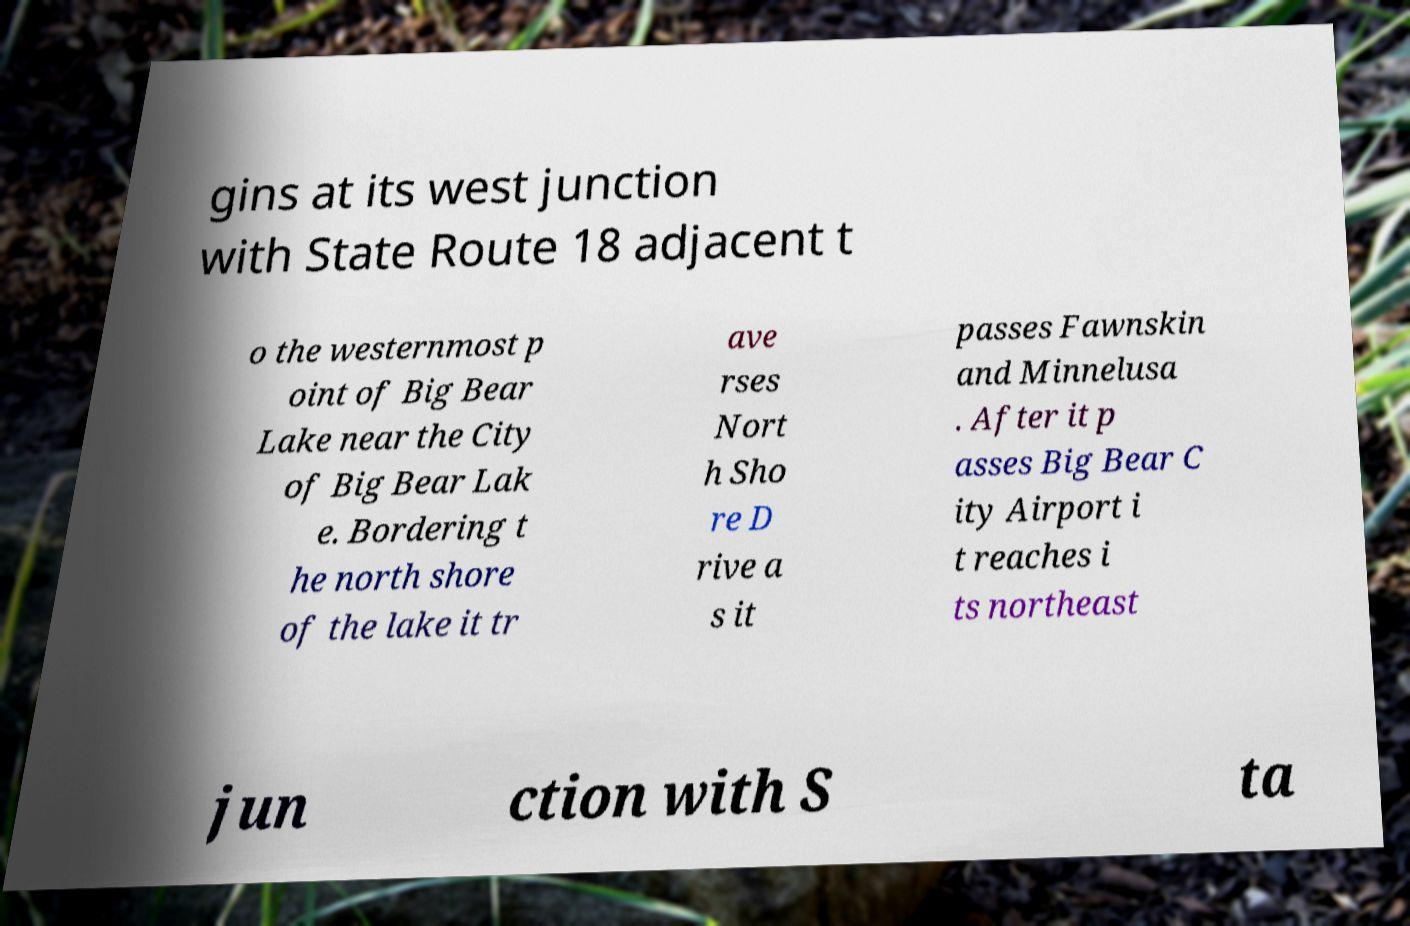I need the written content from this picture converted into text. Can you do that? gins at its west junction with State Route 18 adjacent t o the westernmost p oint of Big Bear Lake near the City of Big Bear Lak e. Bordering t he north shore of the lake it tr ave rses Nort h Sho re D rive a s it passes Fawnskin and Minnelusa . After it p asses Big Bear C ity Airport i t reaches i ts northeast jun ction with S ta 